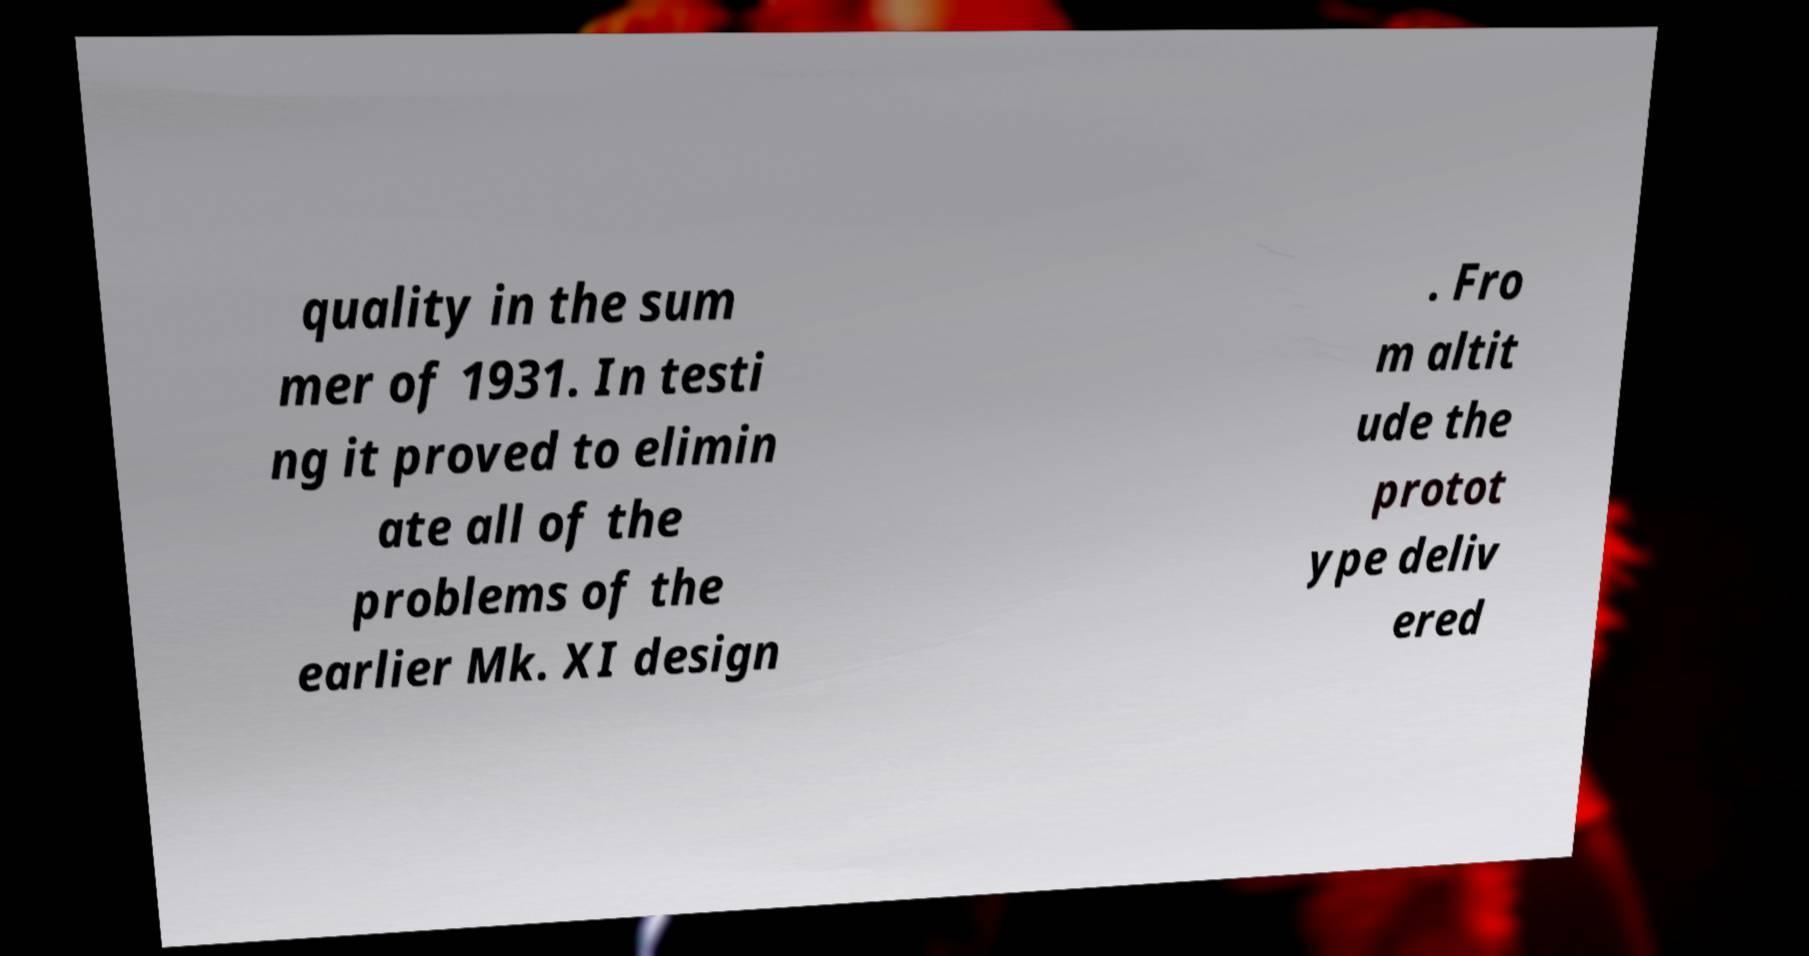Could you assist in decoding the text presented in this image and type it out clearly? quality in the sum mer of 1931. In testi ng it proved to elimin ate all of the problems of the earlier Mk. XI design . Fro m altit ude the protot ype deliv ered 